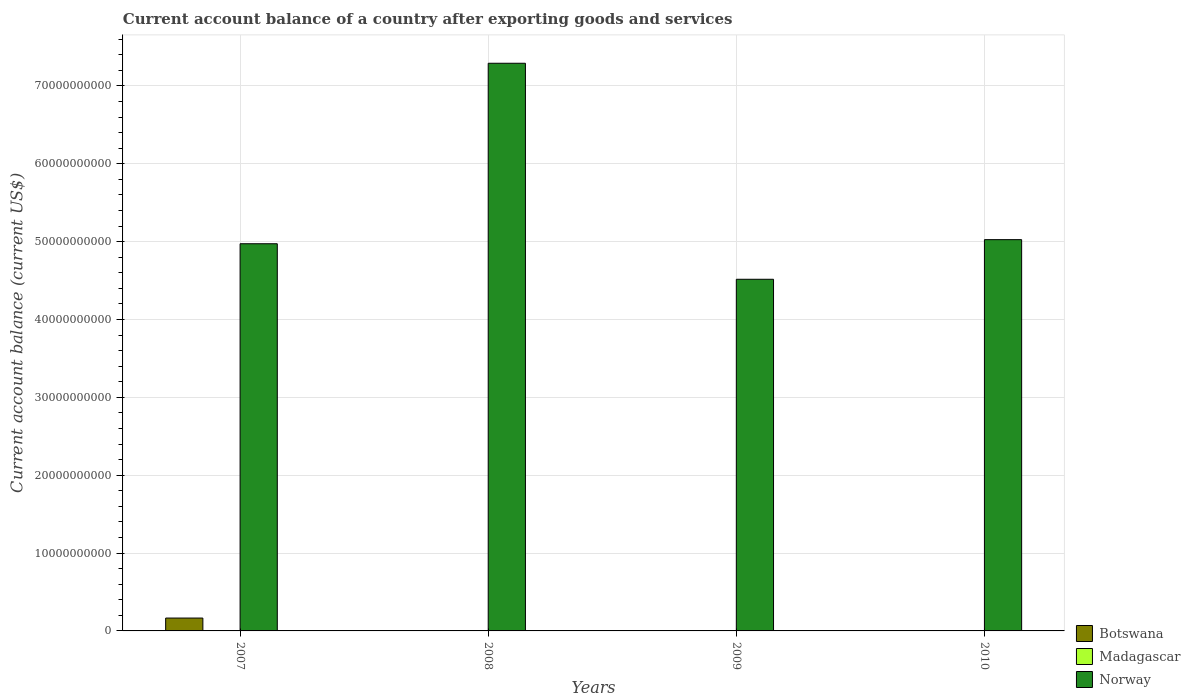How many different coloured bars are there?
Offer a terse response. 2. Are the number of bars per tick equal to the number of legend labels?
Offer a terse response. No. Are the number of bars on each tick of the X-axis equal?
Give a very brief answer. No. How many bars are there on the 3rd tick from the right?
Your answer should be compact. 1. What is the account balance in Botswana in 2008?
Offer a terse response. 0. Across all years, what is the maximum account balance in Norway?
Provide a short and direct response. 7.29e+1. Across all years, what is the minimum account balance in Botswana?
Provide a short and direct response. 0. In which year was the account balance in Botswana maximum?
Provide a succinct answer. 2007. What is the difference between the account balance in Norway in 2007 and that in 2010?
Your response must be concise. -5.26e+08. What is the difference between the account balance in Madagascar in 2010 and the account balance in Norway in 2009?
Your answer should be compact. -4.52e+1. What is the average account balance in Norway per year?
Your answer should be compact. 5.45e+1. In the year 2007, what is the difference between the account balance in Botswana and account balance in Norway?
Your answer should be compact. -4.81e+1. What is the ratio of the account balance in Norway in 2007 to that in 2009?
Offer a terse response. 1.1. Is the account balance in Norway in 2009 less than that in 2010?
Make the answer very short. Yes. What is the difference between the highest and the second highest account balance in Norway?
Provide a succinct answer. 2.27e+1. What is the difference between the highest and the lowest account balance in Botswana?
Give a very brief answer. 1.65e+09. In how many years, is the account balance in Botswana greater than the average account balance in Botswana taken over all years?
Your answer should be very brief. 1. Is the sum of the account balance in Norway in 2008 and 2010 greater than the maximum account balance in Botswana across all years?
Offer a terse response. Yes. How many bars are there?
Give a very brief answer. 5. Are all the bars in the graph horizontal?
Ensure brevity in your answer.  No. Does the graph contain grids?
Give a very brief answer. Yes. Where does the legend appear in the graph?
Provide a short and direct response. Bottom right. How many legend labels are there?
Your response must be concise. 3. How are the legend labels stacked?
Your answer should be compact. Vertical. What is the title of the graph?
Make the answer very short. Current account balance of a country after exporting goods and services. What is the label or title of the Y-axis?
Your answer should be compact. Current account balance (current US$). What is the Current account balance (current US$) in Botswana in 2007?
Your answer should be compact. 1.65e+09. What is the Current account balance (current US$) of Norway in 2007?
Offer a very short reply. 4.97e+1. What is the Current account balance (current US$) in Norway in 2008?
Provide a succinct answer. 7.29e+1. What is the Current account balance (current US$) of Norway in 2009?
Your answer should be very brief. 4.52e+1. What is the Current account balance (current US$) of Madagascar in 2010?
Your answer should be very brief. 0. What is the Current account balance (current US$) in Norway in 2010?
Provide a short and direct response. 5.03e+1. Across all years, what is the maximum Current account balance (current US$) of Botswana?
Offer a terse response. 1.65e+09. Across all years, what is the maximum Current account balance (current US$) of Norway?
Your answer should be very brief. 7.29e+1. Across all years, what is the minimum Current account balance (current US$) of Norway?
Keep it short and to the point. 4.52e+1. What is the total Current account balance (current US$) of Botswana in the graph?
Ensure brevity in your answer.  1.65e+09. What is the total Current account balance (current US$) in Madagascar in the graph?
Offer a very short reply. 0. What is the total Current account balance (current US$) of Norway in the graph?
Make the answer very short. 2.18e+11. What is the difference between the Current account balance (current US$) in Norway in 2007 and that in 2008?
Offer a terse response. -2.32e+1. What is the difference between the Current account balance (current US$) in Norway in 2007 and that in 2009?
Provide a succinct answer. 4.56e+09. What is the difference between the Current account balance (current US$) of Norway in 2007 and that in 2010?
Ensure brevity in your answer.  -5.26e+08. What is the difference between the Current account balance (current US$) of Norway in 2008 and that in 2009?
Provide a succinct answer. 2.77e+1. What is the difference between the Current account balance (current US$) in Norway in 2008 and that in 2010?
Provide a succinct answer. 2.27e+1. What is the difference between the Current account balance (current US$) of Norway in 2009 and that in 2010?
Your answer should be compact. -5.09e+09. What is the difference between the Current account balance (current US$) in Botswana in 2007 and the Current account balance (current US$) in Norway in 2008?
Ensure brevity in your answer.  -7.13e+1. What is the difference between the Current account balance (current US$) in Botswana in 2007 and the Current account balance (current US$) in Norway in 2009?
Give a very brief answer. -4.35e+1. What is the difference between the Current account balance (current US$) in Botswana in 2007 and the Current account balance (current US$) in Norway in 2010?
Your response must be concise. -4.86e+1. What is the average Current account balance (current US$) in Botswana per year?
Provide a short and direct response. 4.13e+08. What is the average Current account balance (current US$) of Madagascar per year?
Give a very brief answer. 0. What is the average Current account balance (current US$) in Norway per year?
Give a very brief answer. 5.45e+1. In the year 2007, what is the difference between the Current account balance (current US$) of Botswana and Current account balance (current US$) of Norway?
Ensure brevity in your answer.  -4.81e+1. What is the ratio of the Current account balance (current US$) in Norway in 2007 to that in 2008?
Make the answer very short. 0.68. What is the ratio of the Current account balance (current US$) of Norway in 2007 to that in 2009?
Offer a very short reply. 1.1. What is the ratio of the Current account balance (current US$) in Norway in 2008 to that in 2009?
Provide a succinct answer. 1.61. What is the ratio of the Current account balance (current US$) in Norway in 2008 to that in 2010?
Offer a very short reply. 1.45. What is the ratio of the Current account balance (current US$) in Norway in 2009 to that in 2010?
Your answer should be very brief. 0.9. What is the difference between the highest and the second highest Current account balance (current US$) of Norway?
Offer a very short reply. 2.27e+1. What is the difference between the highest and the lowest Current account balance (current US$) of Botswana?
Give a very brief answer. 1.65e+09. What is the difference between the highest and the lowest Current account balance (current US$) in Norway?
Offer a very short reply. 2.77e+1. 